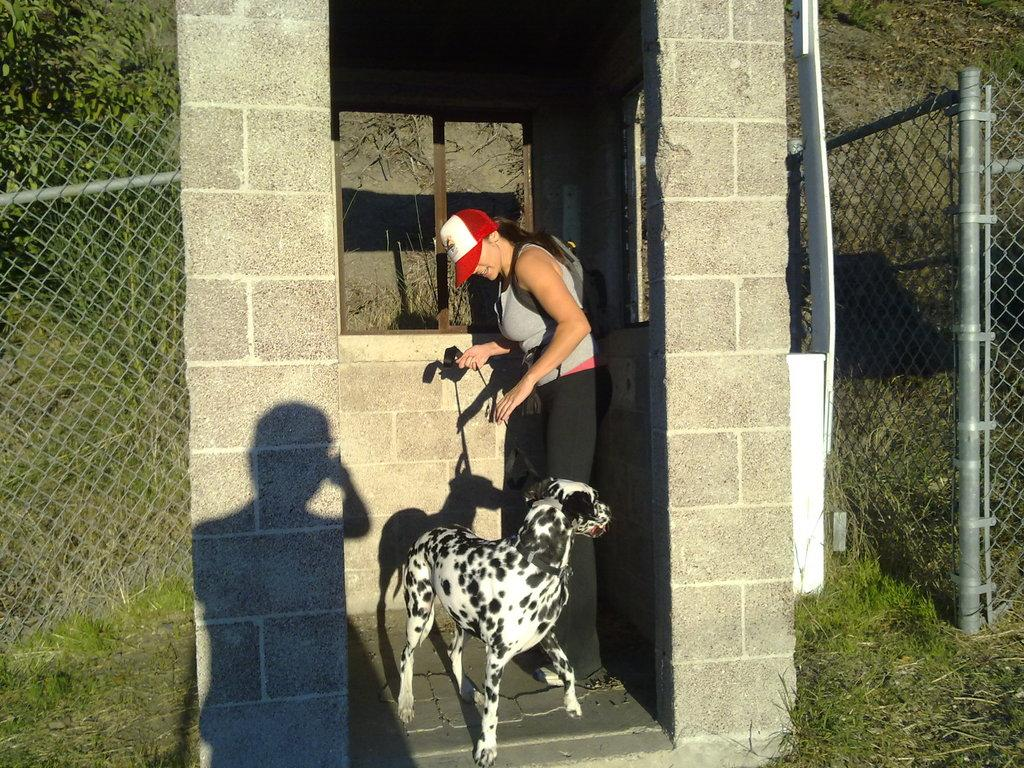What is the main subject of the image? The main subject of the image is a woman. What is the woman wearing on her head? The woman is wearing a cap. What is the woman holding in the image? The woman is holding a dog with a rope. What type of structure can be seen in the image? There is a pillar in the image. What type of barrier is present in the image? There is a net fence in the image. What type of vegetation is visible in the image? There is a plant and a tree with a pole in the image. What type of kite is the woman flying in the image? There is no kite present in the image; the woman is holding a dog with a rope. Is there a fire visible in the image? No, there is no fire visible in the image. What type of stone can be seen in the image? There is no stone present in the image. 